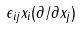<formula> <loc_0><loc_0><loc_500><loc_500>\epsilon _ { i j } x _ { i } ( \partial / \partial x _ { j } )</formula> 